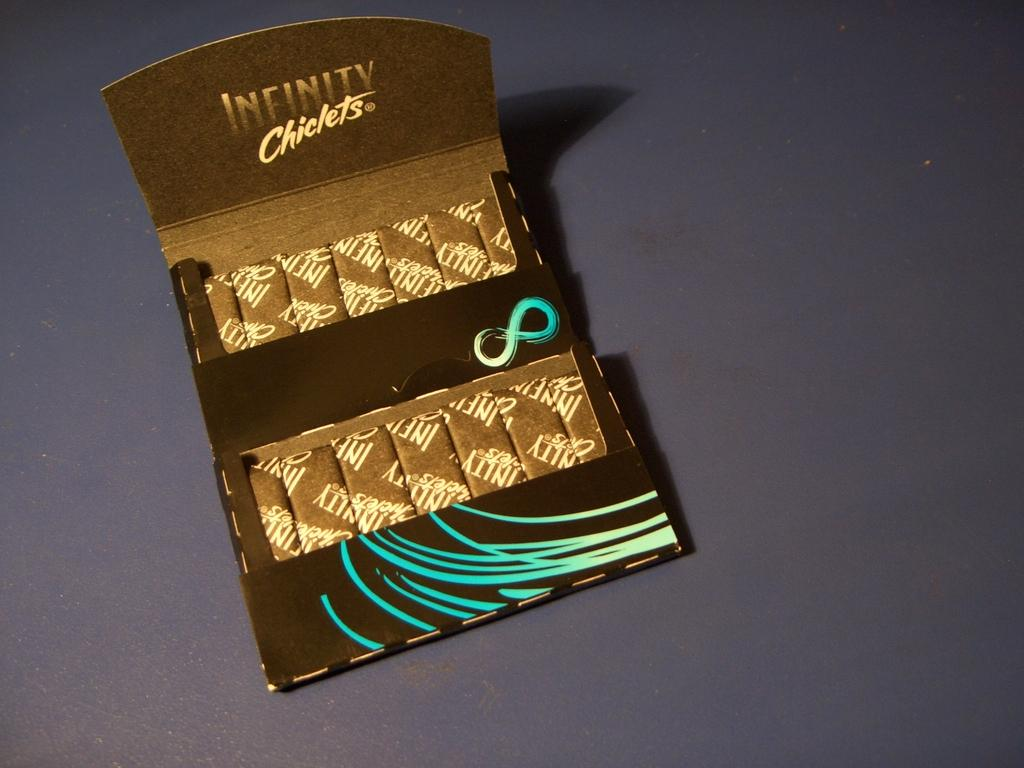Provide a one-sentence caption for the provided image. A packet of Infinity Chiclets on a table. 